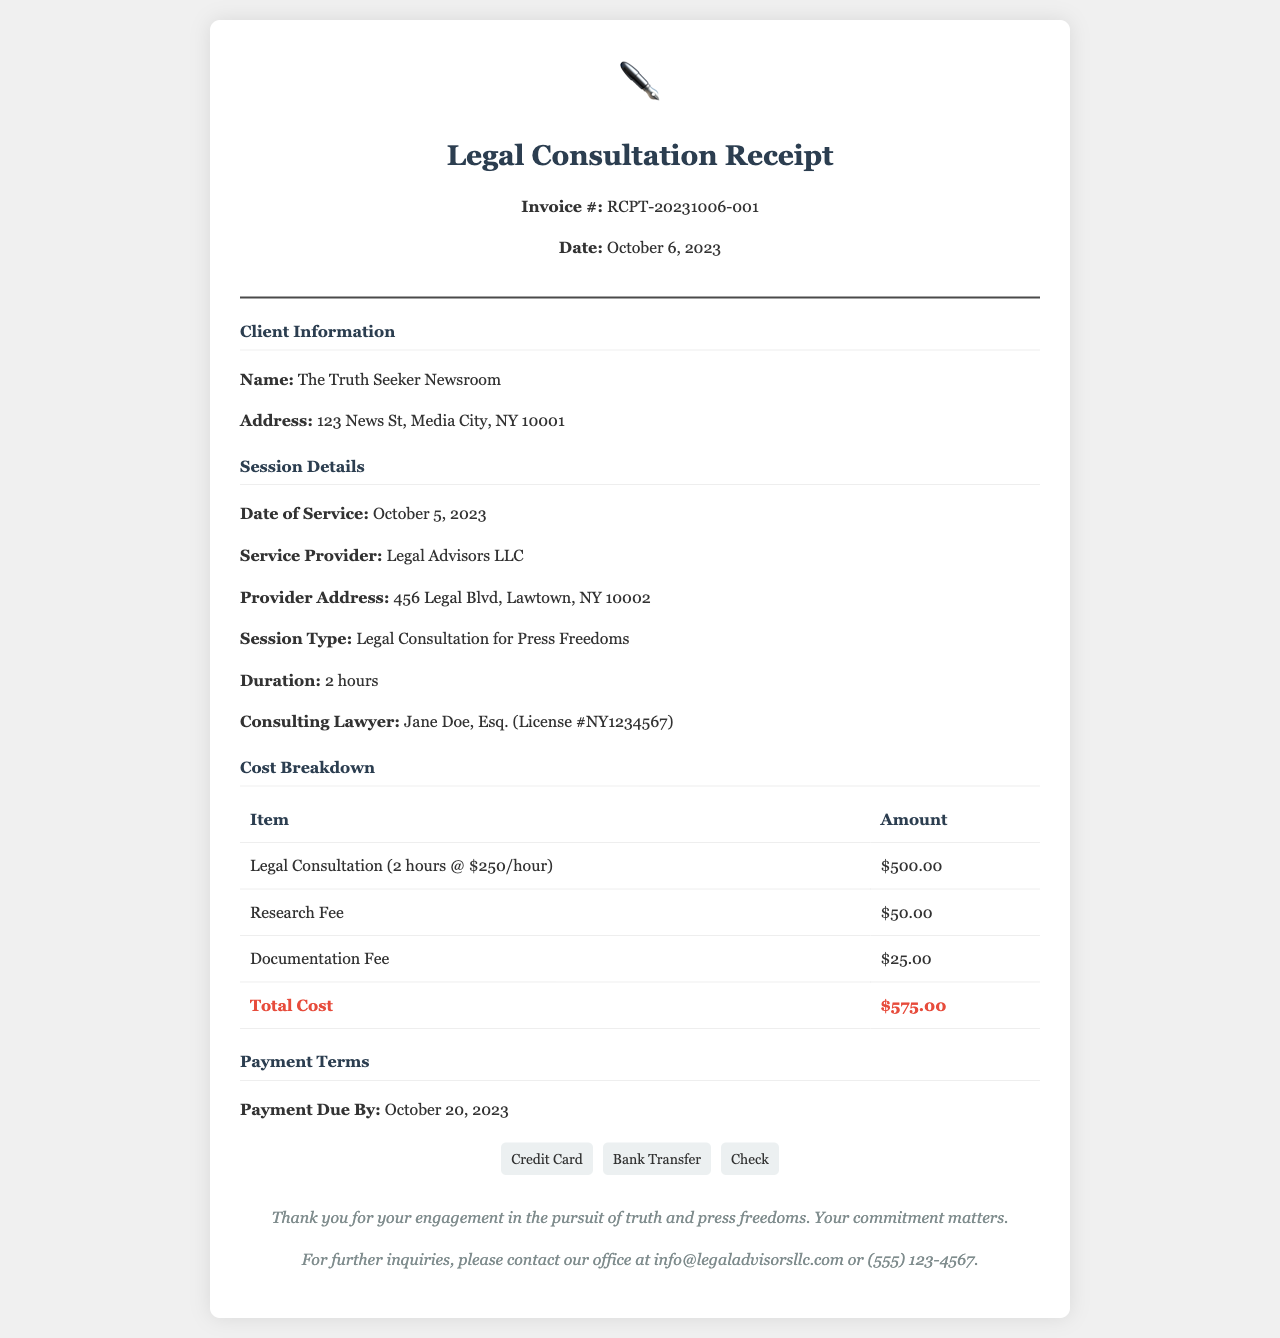what is the invoice number? The invoice number can be found in the header section of the receipt, listed as RCPT-20231006-001.
Answer: RCPT-20231006-001 what is the date of service? The date of service is specified in the session details section of the receipt as October 5, 2023.
Answer: October 5, 2023 who is the consulting lawyer? The consulting lawyer's name is listed in the session details section as Jane Doe, Esq.
Answer: Jane Doe, Esq what is the total cost? The total cost is calculated from the cost breakdown table, which sums up to $575.00.
Answer: $575.00 how much is charged per hour for the legal consultation? The amount charged per hour for the legal consultation is mentioned as $250/hour.
Answer: $250/hour how long was the legal consultation session? The duration of the legal consultation session is stated as 2 hours.
Answer: 2 hours when is the payment due by? The payment due date is mentioned under the payment terms as October 20, 2023.
Answer: October 20, 2023 what are the payment methods available? The payment methods available are provided in the payment terms section as Credit Card, Bank Transfer, and Check.
Answer: Credit Card, Bank Transfer, Check who is the service provider? The service provider is identified in the session details section as Legal Advisors LLC.
Answer: Legal Advisors LLC 